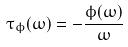<formula> <loc_0><loc_0><loc_500><loc_500>\tau _ { \phi } ( \omega ) = - \frac { \phi ( \omega ) } { \omega }</formula> 